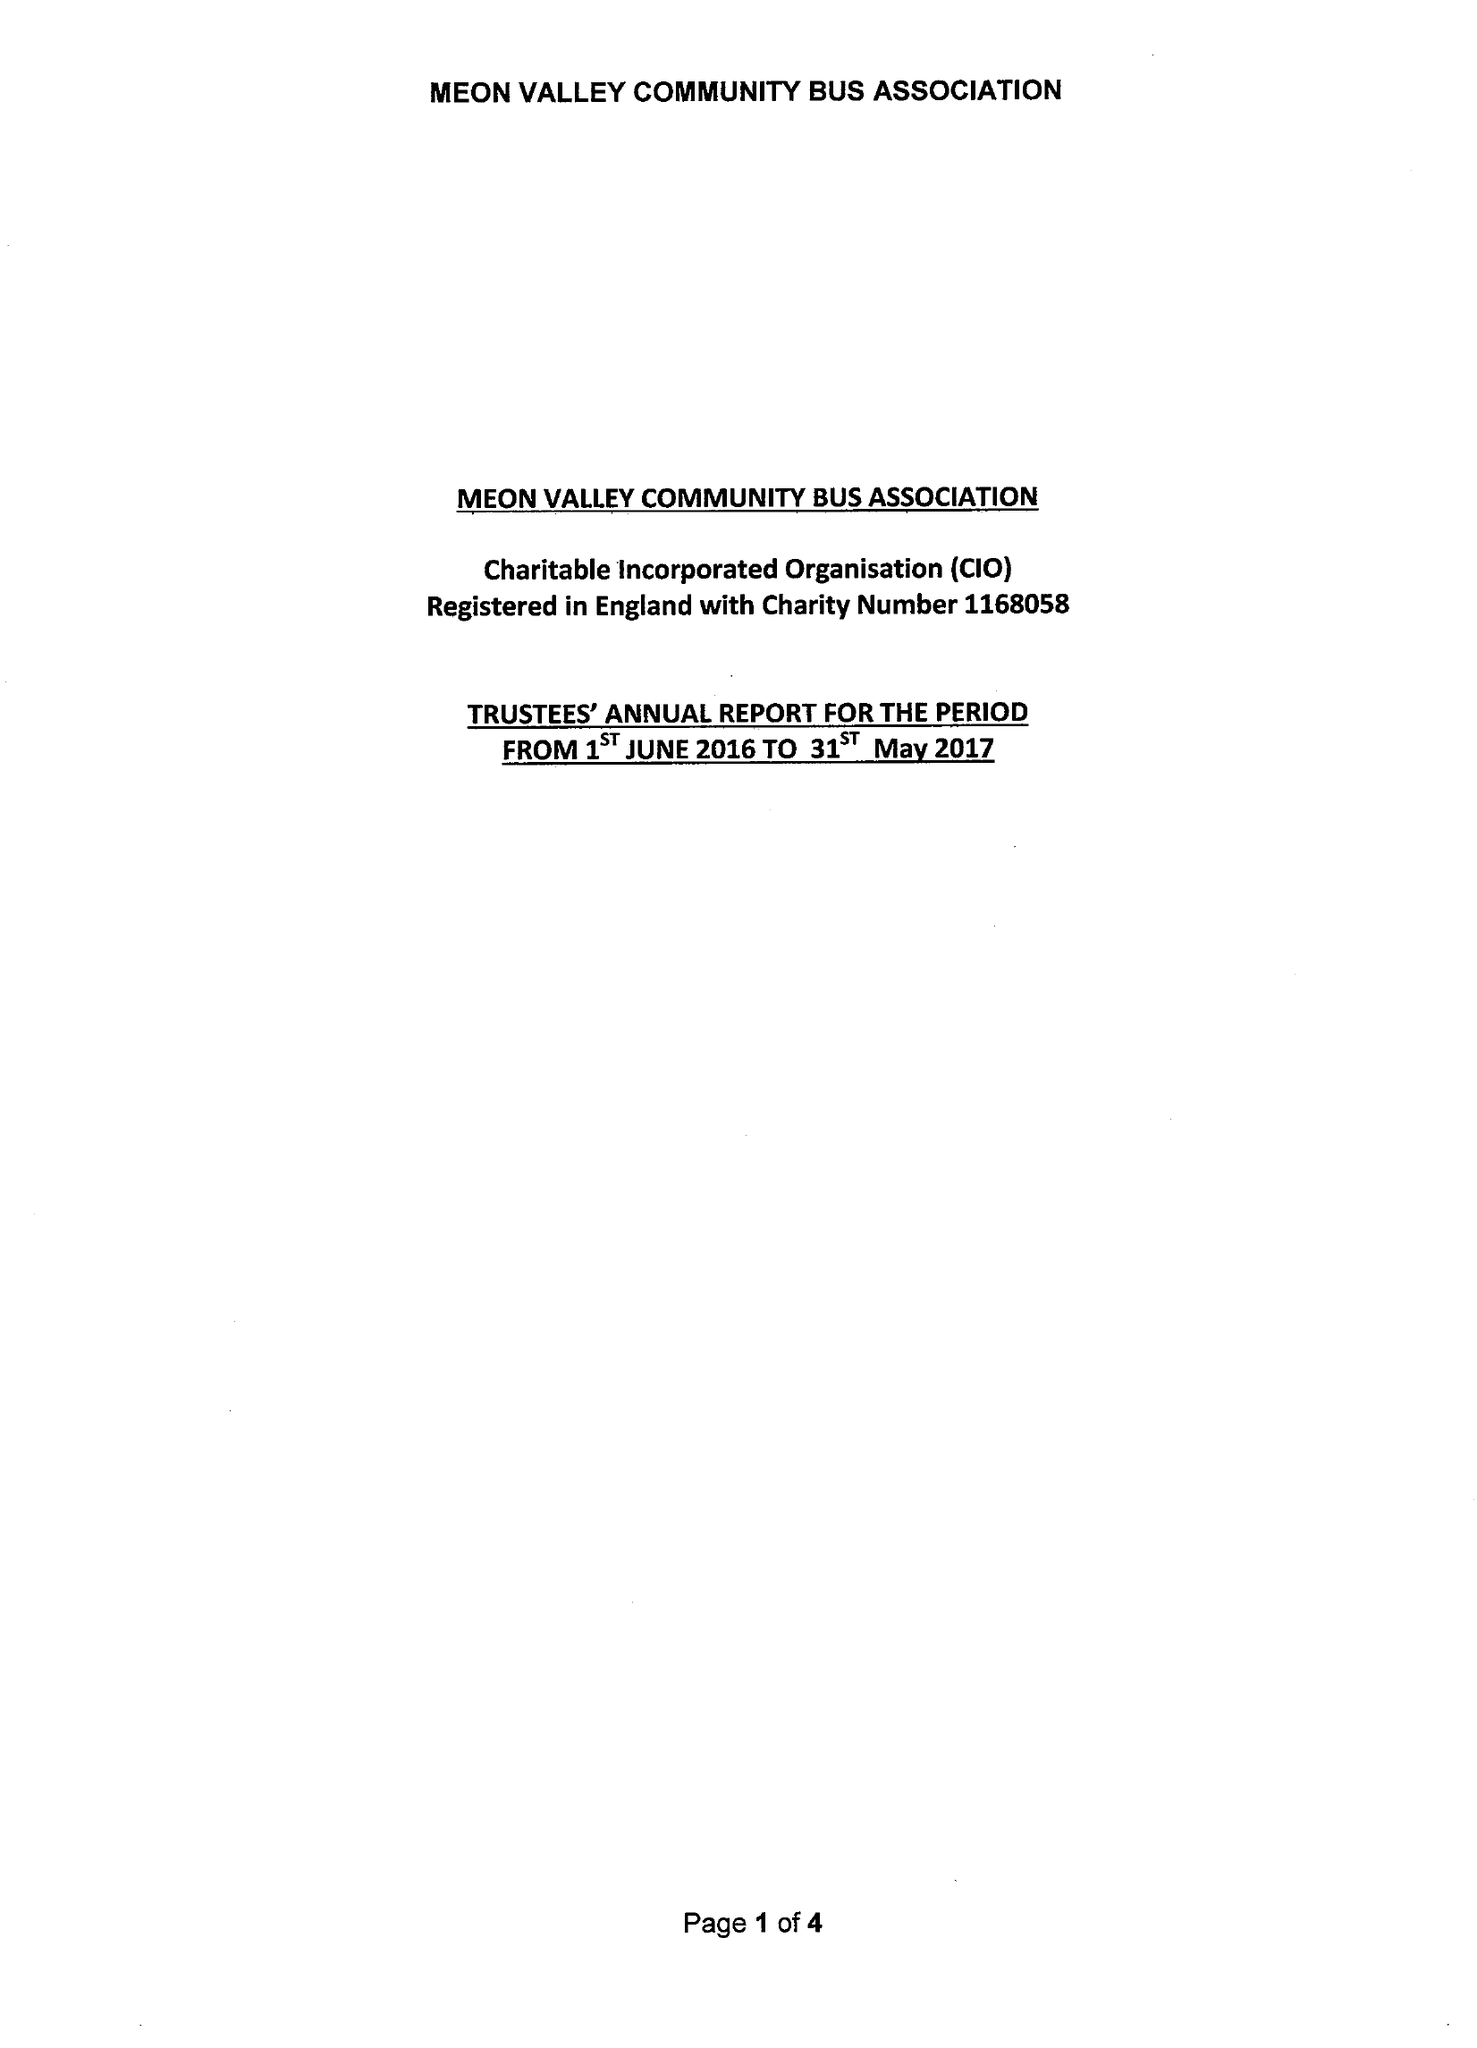What is the value for the address__post_town?
Answer the question using a single word or phrase. SOUTHAMPTON 